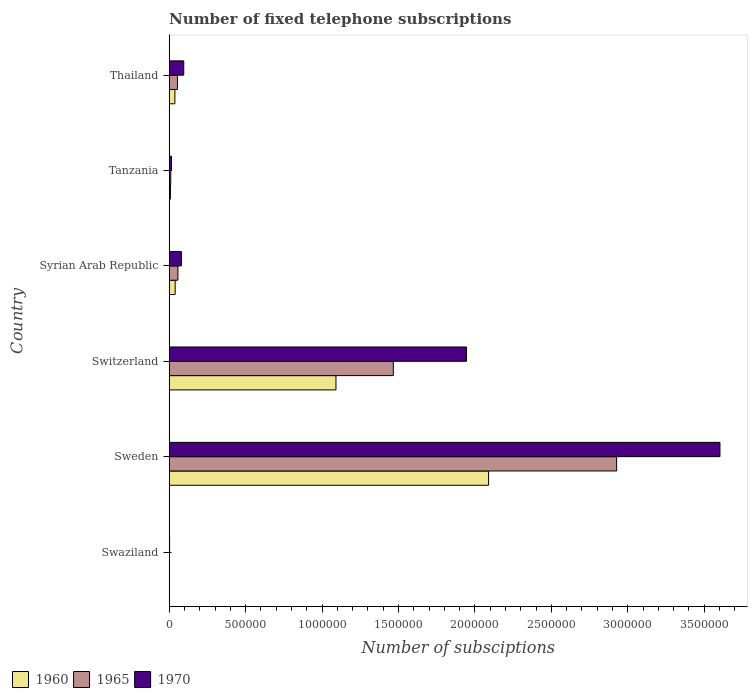How many groups of bars are there?
Offer a very short reply. 6. Are the number of bars per tick equal to the number of legend labels?
Offer a terse response. Yes. How many bars are there on the 2nd tick from the bottom?
Offer a very short reply. 3. What is the label of the 1st group of bars from the top?
Provide a succinct answer. Thailand. What is the number of fixed telephone subscriptions in 1965 in Tanzania?
Make the answer very short. 1.02e+04. Across all countries, what is the maximum number of fixed telephone subscriptions in 1965?
Your answer should be very brief. 2.93e+06. Across all countries, what is the minimum number of fixed telephone subscriptions in 1960?
Make the answer very short. 1200. In which country was the number of fixed telephone subscriptions in 1965 maximum?
Ensure brevity in your answer.  Sweden. In which country was the number of fixed telephone subscriptions in 1960 minimum?
Your answer should be very brief. Swaziland. What is the total number of fixed telephone subscriptions in 1965 in the graph?
Provide a succinct answer. 4.52e+06. What is the difference between the number of fixed telephone subscriptions in 1960 in Switzerland and that in Syrian Arab Republic?
Your answer should be compact. 1.05e+06. What is the difference between the number of fixed telephone subscriptions in 1960 in Thailand and the number of fixed telephone subscriptions in 1970 in Tanzania?
Give a very brief answer. 2.22e+04. What is the average number of fixed telephone subscriptions in 1970 per country?
Your answer should be very brief. 9.57e+05. What is the difference between the number of fixed telephone subscriptions in 1965 and number of fixed telephone subscriptions in 1960 in Thailand?
Offer a very short reply. 1.69e+04. What is the ratio of the number of fixed telephone subscriptions in 1970 in Sweden to that in Thailand?
Make the answer very short. 37.93. Is the difference between the number of fixed telephone subscriptions in 1965 in Tanzania and Thailand greater than the difference between the number of fixed telephone subscriptions in 1960 in Tanzania and Thailand?
Your answer should be very brief. No. What is the difference between the highest and the second highest number of fixed telephone subscriptions in 1960?
Make the answer very short. 9.98e+05. What is the difference between the highest and the lowest number of fixed telephone subscriptions in 1960?
Offer a very short reply. 2.09e+06. In how many countries, is the number of fixed telephone subscriptions in 1960 greater than the average number of fixed telephone subscriptions in 1960 taken over all countries?
Offer a terse response. 2. What does the 2nd bar from the bottom in Thailand represents?
Offer a terse response. 1965. How many bars are there?
Give a very brief answer. 18. Are all the bars in the graph horizontal?
Ensure brevity in your answer.  Yes. What is the difference between two consecutive major ticks on the X-axis?
Your response must be concise. 5.00e+05. What is the title of the graph?
Offer a terse response. Number of fixed telephone subscriptions. Does "2005" appear as one of the legend labels in the graph?
Your answer should be compact. No. What is the label or title of the X-axis?
Offer a very short reply. Number of subsciptions. What is the label or title of the Y-axis?
Offer a very short reply. Country. What is the Number of subsciptions in 1960 in Swaziland?
Provide a succinct answer. 1200. What is the Number of subsciptions in 1965 in Swaziland?
Your answer should be compact. 2000. What is the Number of subsciptions of 1970 in Swaziland?
Offer a terse response. 2500. What is the Number of subsciptions of 1960 in Sweden?
Keep it short and to the point. 2.09e+06. What is the Number of subsciptions of 1965 in Sweden?
Provide a short and direct response. 2.93e+06. What is the Number of subsciptions of 1970 in Sweden?
Keep it short and to the point. 3.60e+06. What is the Number of subsciptions of 1960 in Switzerland?
Ensure brevity in your answer.  1.09e+06. What is the Number of subsciptions in 1965 in Switzerland?
Keep it short and to the point. 1.47e+06. What is the Number of subsciptions of 1970 in Switzerland?
Your answer should be very brief. 1.94e+06. What is the Number of subsciptions of 1960 in Syrian Arab Republic?
Ensure brevity in your answer.  3.89e+04. What is the Number of subsciptions in 1965 in Syrian Arab Republic?
Your response must be concise. 5.70e+04. What is the Number of subsciptions of 1970 in Syrian Arab Republic?
Make the answer very short. 7.98e+04. What is the Number of subsciptions in 1960 in Tanzania?
Make the answer very short. 8130. What is the Number of subsciptions of 1965 in Tanzania?
Keep it short and to the point. 1.02e+04. What is the Number of subsciptions of 1970 in Tanzania?
Your answer should be very brief. 1.50e+04. What is the Number of subsciptions of 1960 in Thailand?
Your answer should be very brief. 3.71e+04. What is the Number of subsciptions in 1965 in Thailand?
Offer a very short reply. 5.40e+04. What is the Number of subsciptions of 1970 in Thailand?
Provide a succinct answer. 9.50e+04. Across all countries, what is the maximum Number of subsciptions of 1960?
Offer a terse response. 2.09e+06. Across all countries, what is the maximum Number of subsciptions of 1965?
Ensure brevity in your answer.  2.93e+06. Across all countries, what is the maximum Number of subsciptions of 1970?
Make the answer very short. 3.60e+06. Across all countries, what is the minimum Number of subsciptions in 1960?
Give a very brief answer. 1200. Across all countries, what is the minimum Number of subsciptions of 1970?
Your answer should be compact. 2500. What is the total Number of subsciptions in 1960 in the graph?
Your answer should be compact. 3.27e+06. What is the total Number of subsciptions in 1965 in the graph?
Make the answer very short. 4.52e+06. What is the total Number of subsciptions of 1970 in the graph?
Your answer should be very brief. 5.74e+06. What is the difference between the Number of subsciptions of 1960 in Swaziland and that in Sweden?
Provide a short and direct response. -2.09e+06. What is the difference between the Number of subsciptions of 1965 in Swaziland and that in Sweden?
Your response must be concise. -2.92e+06. What is the difference between the Number of subsciptions in 1970 in Swaziland and that in Sweden?
Make the answer very short. -3.60e+06. What is the difference between the Number of subsciptions of 1960 in Swaziland and that in Switzerland?
Your response must be concise. -1.09e+06. What is the difference between the Number of subsciptions in 1965 in Swaziland and that in Switzerland?
Ensure brevity in your answer.  -1.46e+06. What is the difference between the Number of subsciptions of 1970 in Swaziland and that in Switzerland?
Ensure brevity in your answer.  -1.94e+06. What is the difference between the Number of subsciptions in 1960 in Swaziland and that in Syrian Arab Republic?
Keep it short and to the point. -3.77e+04. What is the difference between the Number of subsciptions of 1965 in Swaziland and that in Syrian Arab Republic?
Your answer should be compact. -5.50e+04. What is the difference between the Number of subsciptions of 1970 in Swaziland and that in Syrian Arab Republic?
Offer a terse response. -7.73e+04. What is the difference between the Number of subsciptions of 1960 in Swaziland and that in Tanzania?
Make the answer very short. -6930. What is the difference between the Number of subsciptions of 1965 in Swaziland and that in Tanzania?
Offer a very short reply. -8231. What is the difference between the Number of subsciptions in 1970 in Swaziland and that in Tanzania?
Provide a short and direct response. -1.25e+04. What is the difference between the Number of subsciptions in 1960 in Swaziland and that in Thailand?
Ensure brevity in your answer.  -3.59e+04. What is the difference between the Number of subsciptions in 1965 in Swaziland and that in Thailand?
Provide a succinct answer. -5.20e+04. What is the difference between the Number of subsciptions in 1970 in Swaziland and that in Thailand?
Give a very brief answer. -9.25e+04. What is the difference between the Number of subsciptions in 1960 in Sweden and that in Switzerland?
Offer a very short reply. 9.98e+05. What is the difference between the Number of subsciptions of 1965 in Sweden and that in Switzerland?
Ensure brevity in your answer.  1.46e+06. What is the difference between the Number of subsciptions of 1970 in Sweden and that in Switzerland?
Your response must be concise. 1.66e+06. What is the difference between the Number of subsciptions of 1960 in Sweden and that in Syrian Arab Republic?
Provide a short and direct response. 2.05e+06. What is the difference between the Number of subsciptions of 1965 in Sweden and that in Syrian Arab Republic?
Your response must be concise. 2.87e+06. What is the difference between the Number of subsciptions in 1970 in Sweden and that in Syrian Arab Republic?
Make the answer very short. 3.52e+06. What is the difference between the Number of subsciptions in 1960 in Sweden and that in Tanzania?
Make the answer very short. 2.08e+06. What is the difference between the Number of subsciptions of 1965 in Sweden and that in Tanzania?
Give a very brief answer. 2.92e+06. What is the difference between the Number of subsciptions of 1970 in Sweden and that in Tanzania?
Offer a very short reply. 3.59e+06. What is the difference between the Number of subsciptions in 1960 in Sweden and that in Thailand?
Your answer should be compact. 2.05e+06. What is the difference between the Number of subsciptions in 1965 in Sweden and that in Thailand?
Offer a very short reply. 2.87e+06. What is the difference between the Number of subsciptions in 1970 in Sweden and that in Thailand?
Offer a very short reply. 3.51e+06. What is the difference between the Number of subsciptions in 1960 in Switzerland and that in Syrian Arab Republic?
Provide a succinct answer. 1.05e+06. What is the difference between the Number of subsciptions of 1965 in Switzerland and that in Syrian Arab Republic?
Offer a very short reply. 1.41e+06. What is the difference between the Number of subsciptions of 1970 in Switzerland and that in Syrian Arab Republic?
Your answer should be very brief. 1.87e+06. What is the difference between the Number of subsciptions of 1960 in Switzerland and that in Tanzania?
Offer a terse response. 1.08e+06. What is the difference between the Number of subsciptions of 1965 in Switzerland and that in Tanzania?
Offer a very short reply. 1.46e+06. What is the difference between the Number of subsciptions of 1970 in Switzerland and that in Tanzania?
Your answer should be compact. 1.93e+06. What is the difference between the Number of subsciptions in 1960 in Switzerland and that in Thailand?
Your response must be concise. 1.05e+06. What is the difference between the Number of subsciptions in 1965 in Switzerland and that in Thailand?
Provide a succinct answer. 1.41e+06. What is the difference between the Number of subsciptions of 1970 in Switzerland and that in Thailand?
Your response must be concise. 1.85e+06. What is the difference between the Number of subsciptions in 1960 in Syrian Arab Republic and that in Tanzania?
Provide a succinct answer. 3.08e+04. What is the difference between the Number of subsciptions in 1965 in Syrian Arab Republic and that in Tanzania?
Offer a terse response. 4.68e+04. What is the difference between the Number of subsciptions of 1970 in Syrian Arab Republic and that in Tanzania?
Offer a very short reply. 6.48e+04. What is the difference between the Number of subsciptions in 1960 in Syrian Arab Republic and that in Thailand?
Ensure brevity in your answer.  1737. What is the difference between the Number of subsciptions of 1965 in Syrian Arab Republic and that in Thailand?
Your response must be concise. 3000. What is the difference between the Number of subsciptions in 1970 in Syrian Arab Republic and that in Thailand?
Keep it short and to the point. -1.52e+04. What is the difference between the Number of subsciptions of 1960 in Tanzania and that in Thailand?
Make the answer very short. -2.90e+04. What is the difference between the Number of subsciptions in 1965 in Tanzania and that in Thailand?
Ensure brevity in your answer.  -4.38e+04. What is the difference between the Number of subsciptions of 1970 in Tanzania and that in Thailand?
Your answer should be compact. -8.00e+04. What is the difference between the Number of subsciptions of 1960 in Swaziland and the Number of subsciptions of 1965 in Sweden?
Keep it short and to the point. -2.93e+06. What is the difference between the Number of subsciptions in 1960 in Swaziland and the Number of subsciptions in 1970 in Sweden?
Ensure brevity in your answer.  -3.60e+06. What is the difference between the Number of subsciptions of 1965 in Swaziland and the Number of subsciptions of 1970 in Sweden?
Offer a terse response. -3.60e+06. What is the difference between the Number of subsciptions of 1960 in Swaziland and the Number of subsciptions of 1965 in Switzerland?
Keep it short and to the point. -1.46e+06. What is the difference between the Number of subsciptions of 1960 in Swaziland and the Number of subsciptions of 1970 in Switzerland?
Give a very brief answer. -1.94e+06. What is the difference between the Number of subsciptions of 1965 in Swaziland and the Number of subsciptions of 1970 in Switzerland?
Offer a terse response. -1.94e+06. What is the difference between the Number of subsciptions of 1960 in Swaziland and the Number of subsciptions of 1965 in Syrian Arab Republic?
Your answer should be compact. -5.58e+04. What is the difference between the Number of subsciptions in 1960 in Swaziland and the Number of subsciptions in 1970 in Syrian Arab Republic?
Make the answer very short. -7.86e+04. What is the difference between the Number of subsciptions of 1965 in Swaziland and the Number of subsciptions of 1970 in Syrian Arab Republic?
Your answer should be very brief. -7.78e+04. What is the difference between the Number of subsciptions of 1960 in Swaziland and the Number of subsciptions of 1965 in Tanzania?
Your response must be concise. -9031. What is the difference between the Number of subsciptions in 1960 in Swaziland and the Number of subsciptions in 1970 in Tanzania?
Your response must be concise. -1.38e+04. What is the difference between the Number of subsciptions of 1965 in Swaziland and the Number of subsciptions of 1970 in Tanzania?
Keep it short and to the point. -1.30e+04. What is the difference between the Number of subsciptions of 1960 in Swaziland and the Number of subsciptions of 1965 in Thailand?
Offer a terse response. -5.28e+04. What is the difference between the Number of subsciptions in 1960 in Swaziland and the Number of subsciptions in 1970 in Thailand?
Ensure brevity in your answer.  -9.38e+04. What is the difference between the Number of subsciptions in 1965 in Swaziland and the Number of subsciptions in 1970 in Thailand?
Provide a succinct answer. -9.30e+04. What is the difference between the Number of subsciptions of 1960 in Sweden and the Number of subsciptions of 1965 in Switzerland?
Provide a succinct answer. 6.23e+05. What is the difference between the Number of subsciptions of 1960 in Sweden and the Number of subsciptions of 1970 in Switzerland?
Offer a terse response. 1.44e+05. What is the difference between the Number of subsciptions of 1965 in Sweden and the Number of subsciptions of 1970 in Switzerland?
Keep it short and to the point. 9.82e+05. What is the difference between the Number of subsciptions of 1960 in Sweden and the Number of subsciptions of 1965 in Syrian Arab Republic?
Your answer should be compact. 2.03e+06. What is the difference between the Number of subsciptions of 1960 in Sweden and the Number of subsciptions of 1970 in Syrian Arab Republic?
Your answer should be very brief. 2.01e+06. What is the difference between the Number of subsciptions of 1965 in Sweden and the Number of subsciptions of 1970 in Syrian Arab Republic?
Provide a succinct answer. 2.85e+06. What is the difference between the Number of subsciptions in 1960 in Sweden and the Number of subsciptions in 1965 in Tanzania?
Give a very brief answer. 2.08e+06. What is the difference between the Number of subsciptions of 1960 in Sweden and the Number of subsciptions of 1970 in Tanzania?
Offer a very short reply. 2.07e+06. What is the difference between the Number of subsciptions of 1965 in Sweden and the Number of subsciptions of 1970 in Tanzania?
Offer a terse response. 2.91e+06. What is the difference between the Number of subsciptions of 1960 in Sweden and the Number of subsciptions of 1965 in Thailand?
Keep it short and to the point. 2.04e+06. What is the difference between the Number of subsciptions in 1960 in Sweden and the Number of subsciptions in 1970 in Thailand?
Keep it short and to the point. 1.99e+06. What is the difference between the Number of subsciptions in 1965 in Sweden and the Number of subsciptions in 1970 in Thailand?
Provide a succinct answer. 2.83e+06. What is the difference between the Number of subsciptions in 1960 in Switzerland and the Number of subsciptions in 1965 in Syrian Arab Republic?
Your answer should be compact. 1.03e+06. What is the difference between the Number of subsciptions of 1960 in Switzerland and the Number of subsciptions of 1970 in Syrian Arab Republic?
Make the answer very short. 1.01e+06. What is the difference between the Number of subsciptions of 1965 in Switzerland and the Number of subsciptions of 1970 in Syrian Arab Republic?
Give a very brief answer. 1.39e+06. What is the difference between the Number of subsciptions of 1960 in Switzerland and the Number of subsciptions of 1965 in Tanzania?
Your answer should be very brief. 1.08e+06. What is the difference between the Number of subsciptions of 1960 in Switzerland and the Number of subsciptions of 1970 in Tanzania?
Keep it short and to the point. 1.08e+06. What is the difference between the Number of subsciptions of 1965 in Switzerland and the Number of subsciptions of 1970 in Tanzania?
Keep it short and to the point. 1.45e+06. What is the difference between the Number of subsciptions of 1960 in Switzerland and the Number of subsciptions of 1965 in Thailand?
Offer a very short reply. 1.04e+06. What is the difference between the Number of subsciptions in 1960 in Switzerland and the Number of subsciptions in 1970 in Thailand?
Offer a very short reply. 9.96e+05. What is the difference between the Number of subsciptions of 1965 in Switzerland and the Number of subsciptions of 1970 in Thailand?
Ensure brevity in your answer.  1.37e+06. What is the difference between the Number of subsciptions in 1960 in Syrian Arab Republic and the Number of subsciptions in 1965 in Tanzania?
Provide a short and direct response. 2.87e+04. What is the difference between the Number of subsciptions of 1960 in Syrian Arab Republic and the Number of subsciptions of 1970 in Tanzania?
Offer a very short reply. 2.39e+04. What is the difference between the Number of subsciptions of 1965 in Syrian Arab Republic and the Number of subsciptions of 1970 in Tanzania?
Provide a succinct answer. 4.20e+04. What is the difference between the Number of subsciptions in 1960 in Syrian Arab Republic and the Number of subsciptions in 1965 in Thailand?
Provide a succinct answer. -1.51e+04. What is the difference between the Number of subsciptions in 1960 in Syrian Arab Republic and the Number of subsciptions in 1970 in Thailand?
Make the answer very short. -5.61e+04. What is the difference between the Number of subsciptions of 1965 in Syrian Arab Republic and the Number of subsciptions of 1970 in Thailand?
Offer a terse response. -3.80e+04. What is the difference between the Number of subsciptions of 1960 in Tanzania and the Number of subsciptions of 1965 in Thailand?
Your answer should be very brief. -4.59e+04. What is the difference between the Number of subsciptions in 1960 in Tanzania and the Number of subsciptions in 1970 in Thailand?
Offer a terse response. -8.69e+04. What is the difference between the Number of subsciptions in 1965 in Tanzania and the Number of subsciptions in 1970 in Thailand?
Your response must be concise. -8.48e+04. What is the average Number of subsciptions of 1960 per country?
Make the answer very short. 5.44e+05. What is the average Number of subsciptions in 1965 per country?
Ensure brevity in your answer.  7.53e+05. What is the average Number of subsciptions in 1970 per country?
Ensure brevity in your answer.  9.57e+05. What is the difference between the Number of subsciptions of 1960 and Number of subsciptions of 1965 in Swaziland?
Ensure brevity in your answer.  -800. What is the difference between the Number of subsciptions in 1960 and Number of subsciptions in 1970 in Swaziland?
Ensure brevity in your answer.  -1300. What is the difference between the Number of subsciptions of 1965 and Number of subsciptions of 1970 in Swaziland?
Offer a terse response. -500. What is the difference between the Number of subsciptions in 1960 and Number of subsciptions in 1965 in Sweden?
Offer a terse response. -8.38e+05. What is the difference between the Number of subsciptions of 1960 and Number of subsciptions of 1970 in Sweden?
Offer a terse response. -1.51e+06. What is the difference between the Number of subsciptions in 1965 and Number of subsciptions in 1970 in Sweden?
Provide a succinct answer. -6.76e+05. What is the difference between the Number of subsciptions in 1960 and Number of subsciptions in 1965 in Switzerland?
Provide a succinct answer. -3.75e+05. What is the difference between the Number of subsciptions of 1960 and Number of subsciptions of 1970 in Switzerland?
Give a very brief answer. -8.54e+05. What is the difference between the Number of subsciptions of 1965 and Number of subsciptions of 1970 in Switzerland?
Your answer should be very brief. -4.79e+05. What is the difference between the Number of subsciptions in 1960 and Number of subsciptions in 1965 in Syrian Arab Republic?
Offer a terse response. -1.81e+04. What is the difference between the Number of subsciptions of 1960 and Number of subsciptions of 1970 in Syrian Arab Republic?
Give a very brief answer. -4.09e+04. What is the difference between the Number of subsciptions in 1965 and Number of subsciptions in 1970 in Syrian Arab Republic?
Offer a very short reply. -2.28e+04. What is the difference between the Number of subsciptions of 1960 and Number of subsciptions of 1965 in Tanzania?
Provide a short and direct response. -2101. What is the difference between the Number of subsciptions in 1960 and Number of subsciptions in 1970 in Tanzania?
Your answer should be compact. -6847. What is the difference between the Number of subsciptions of 1965 and Number of subsciptions of 1970 in Tanzania?
Provide a short and direct response. -4746. What is the difference between the Number of subsciptions in 1960 and Number of subsciptions in 1965 in Thailand?
Your response must be concise. -1.69e+04. What is the difference between the Number of subsciptions of 1960 and Number of subsciptions of 1970 in Thailand?
Your response must be concise. -5.79e+04. What is the difference between the Number of subsciptions in 1965 and Number of subsciptions in 1970 in Thailand?
Keep it short and to the point. -4.10e+04. What is the ratio of the Number of subsciptions of 1960 in Swaziland to that in Sweden?
Keep it short and to the point. 0. What is the ratio of the Number of subsciptions in 1965 in Swaziland to that in Sweden?
Offer a terse response. 0. What is the ratio of the Number of subsciptions of 1970 in Swaziland to that in Sweden?
Ensure brevity in your answer.  0. What is the ratio of the Number of subsciptions in 1960 in Swaziland to that in Switzerland?
Provide a succinct answer. 0. What is the ratio of the Number of subsciptions in 1965 in Swaziland to that in Switzerland?
Give a very brief answer. 0. What is the ratio of the Number of subsciptions of 1970 in Swaziland to that in Switzerland?
Make the answer very short. 0. What is the ratio of the Number of subsciptions of 1960 in Swaziland to that in Syrian Arab Republic?
Provide a short and direct response. 0.03. What is the ratio of the Number of subsciptions of 1965 in Swaziland to that in Syrian Arab Republic?
Make the answer very short. 0.04. What is the ratio of the Number of subsciptions in 1970 in Swaziland to that in Syrian Arab Republic?
Give a very brief answer. 0.03. What is the ratio of the Number of subsciptions of 1960 in Swaziland to that in Tanzania?
Make the answer very short. 0.15. What is the ratio of the Number of subsciptions in 1965 in Swaziland to that in Tanzania?
Your response must be concise. 0.2. What is the ratio of the Number of subsciptions in 1970 in Swaziland to that in Tanzania?
Your response must be concise. 0.17. What is the ratio of the Number of subsciptions of 1960 in Swaziland to that in Thailand?
Keep it short and to the point. 0.03. What is the ratio of the Number of subsciptions of 1965 in Swaziland to that in Thailand?
Your response must be concise. 0.04. What is the ratio of the Number of subsciptions in 1970 in Swaziland to that in Thailand?
Your answer should be very brief. 0.03. What is the ratio of the Number of subsciptions of 1960 in Sweden to that in Switzerland?
Provide a short and direct response. 1.92. What is the ratio of the Number of subsciptions of 1965 in Sweden to that in Switzerland?
Offer a very short reply. 2. What is the ratio of the Number of subsciptions in 1970 in Sweden to that in Switzerland?
Make the answer very short. 1.85. What is the ratio of the Number of subsciptions in 1960 in Sweden to that in Syrian Arab Republic?
Make the answer very short. 53.73. What is the ratio of the Number of subsciptions of 1965 in Sweden to that in Syrian Arab Republic?
Offer a very short reply. 51.35. What is the ratio of the Number of subsciptions of 1970 in Sweden to that in Syrian Arab Republic?
Ensure brevity in your answer.  45.15. What is the ratio of the Number of subsciptions of 1960 in Sweden to that in Tanzania?
Make the answer very short. 256.99. What is the ratio of the Number of subsciptions in 1965 in Sweden to that in Tanzania?
Your answer should be compact. 286.09. What is the ratio of the Number of subsciptions in 1970 in Sweden to that in Tanzania?
Provide a short and direct response. 240.57. What is the ratio of the Number of subsciptions in 1960 in Sweden to that in Thailand?
Make the answer very short. 56.24. What is the ratio of the Number of subsciptions of 1965 in Sweden to that in Thailand?
Provide a short and direct response. 54.2. What is the ratio of the Number of subsciptions in 1970 in Sweden to that in Thailand?
Provide a short and direct response. 37.93. What is the ratio of the Number of subsciptions in 1960 in Switzerland to that in Syrian Arab Republic?
Ensure brevity in your answer.  28.06. What is the ratio of the Number of subsciptions of 1965 in Switzerland to that in Syrian Arab Republic?
Your answer should be very brief. 25.72. What is the ratio of the Number of subsciptions in 1970 in Switzerland to that in Syrian Arab Republic?
Offer a very short reply. 24.38. What is the ratio of the Number of subsciptions in 1960 in Switzerland to that in Tanzania?
Ensure brevity in your answer.  134.19. What is the ratio of the Number of subsciptions in 1965 in Switzerland to that in Tanzania?
Your answer should be compact. 143.29. What is the ratio of the Number of subsciptions of 1970 in Switzerland to that in Tanzania?
Make the answer very short. 129.87. What is the ratio of the Number of subsciptions of 1960 in Switzerland to that in Thailand?
Your response must be concise. 29.37. What is the ratio of the Number of subsciptions in 1965 in Switzerland to that in Thailand?
Keep it short and to the point. 27.15. What is the ratio of the Number of subsciptions in 1970 in Switzerland to that in Thailand?
Give a very brief answer. 20.47. What is the ratio of the Number of subsciptions in 1960 in Syrian Arab Republic to that in Tanzania?
Provide a short and direct response. 4.78. What is the ratio of the Number of subsciptions of 1965 in Syrian Arab Republic to that in Tanzania?
Provide a succinct answer. 5.57. What is the ratio of the Number of subsciptions in 1970 in Syrian Arab Republic to that in Tanzania?
Your answer should be very brief. 5.33. What is the ratio of the Number of subsciptions of 1960 in Syrian Arab Republic to that in Thailand?
Your response must be concise. 1.05. What is the ratio of the Number of subsciptions in 1965 in Syrian Arab Republic to that in Thailand?
Make the answer very short. 1.06. What is the ratio of the Number of subsciptions of 1970 in Syrian Arab Republic to that in Thailand?
Offer a very short reply. 0.84. What is the ratio of the Number of subsciptions of 1960 in Tanzania to that in Thailand?
Offer a terse response. 0.22. What is the ratio of the Number of subsciptions in 1965 in Tanzania to that in Thailand?
Make the answer very short. 0.19. What is the ratio of the Number of subsciptions of 1970 in Tanzania to that in Thailand?
Keep it short and to the point. 0.16. What is the difference between the highest and the second highest Number of subsciptions in 1960?
Keep it short and to the point. 9.98e+05. What is the difference between the highest and the second highest Number of subsciptions in 1965?
Your response must be concise. 1.46e+06. What is the difference between the highest and the second highest Number of subsciptions in 1970?
Your answer should be compact. 1.66e+06. What is the difference between the highest and the lowest Number of subsciptions in 1960?
Offer a very short reply. 2.09e+06. What is the difference between the highest and the lowest Number of subsciptions of 1965?
Make the answer very short. 2.92e+06. What is the difference between the highest and the lowest Number of subsciptions of 1970?
Your answer should be very brief. 3.60e+06. 